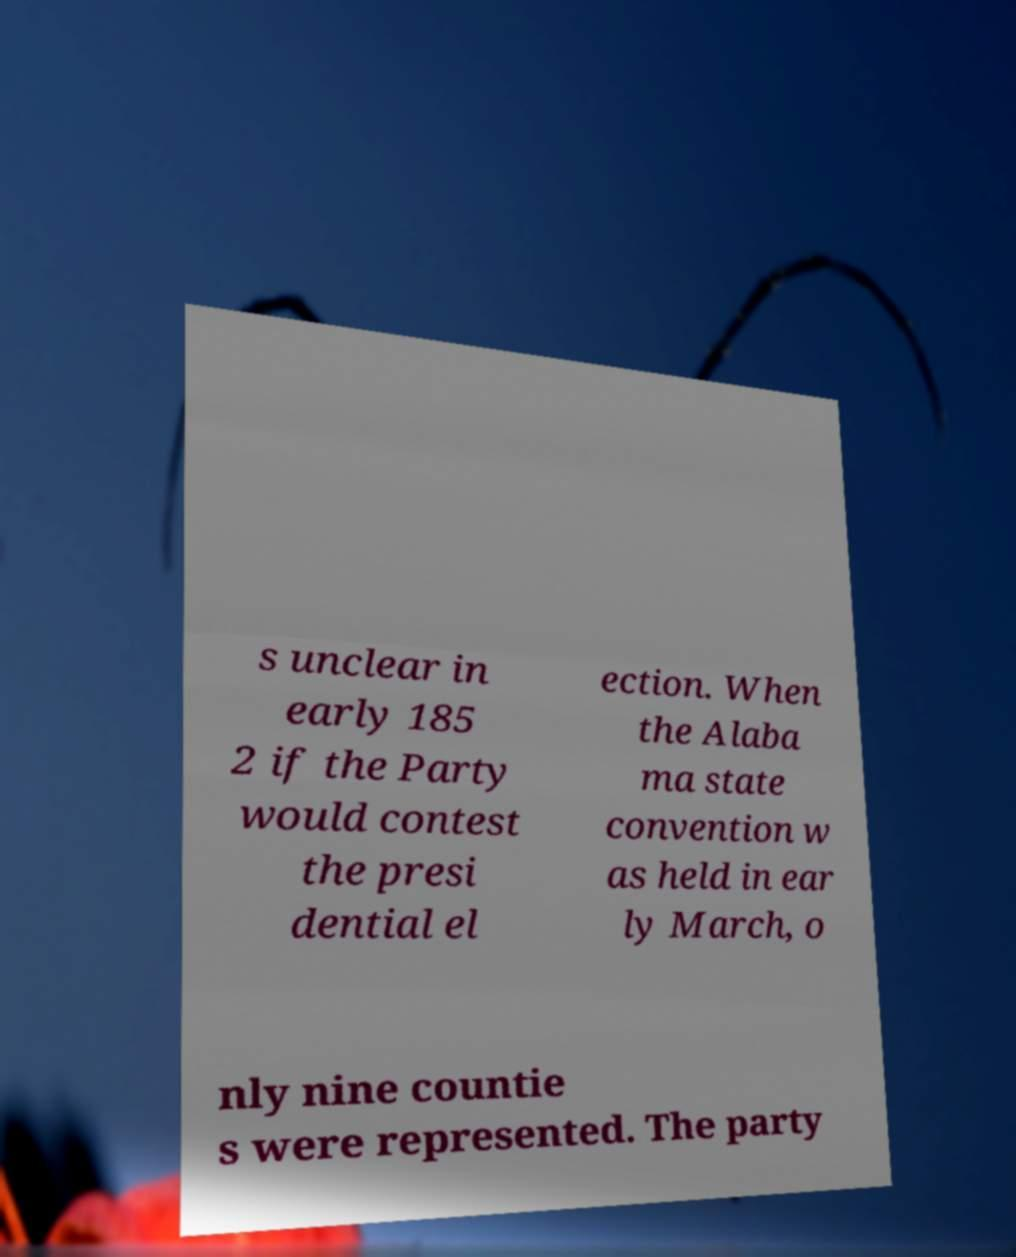Can you read and provide the text displayed in the image?This photo seems to have some interesting text. Can you extract and type it out for me? s unclear in early 185 2 if the Party would contest the presi dential el ection. When the Alaba ma state convention w as held in ear ly March, o nly nine countie s were represented. The party 